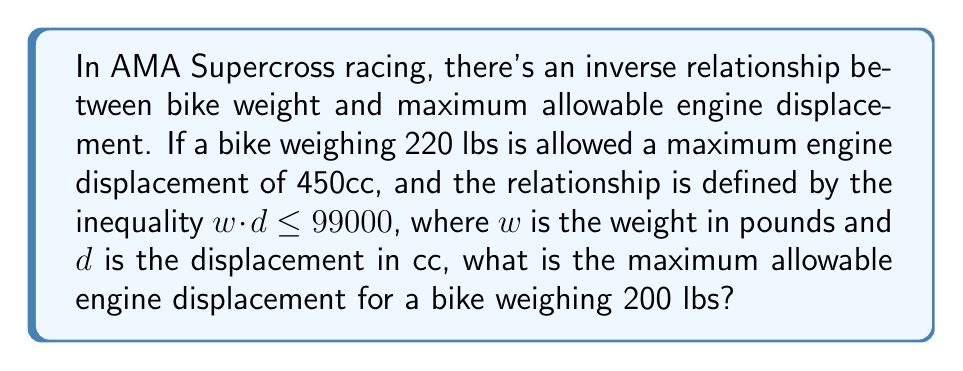Give your solution to this math problem. 1) We're given that the relationship between weight ($w$) and displacement ($d$) is defined by the inequality:

   $w \cdot d \leq 99000$

2) We know that for a 220 lb bike, the maximum displacement is 450cc. Let's verify this:

   $220 \cdot 450 = 99000$

   This confirms that 99000 is indeed the maximum product of weight and displacement.

3) For a 200 lb bike, we need to solve:

   $200 \cdot d \leq 99000$

4) Dividing both sides by 200:

   $d \leq \frac{99000}{200} = 495$

5) Since $d$ represents engine displacement, it must be a whole number. Therefore, the maximum allowable displacement is 495cc.
Answer: 495cc 